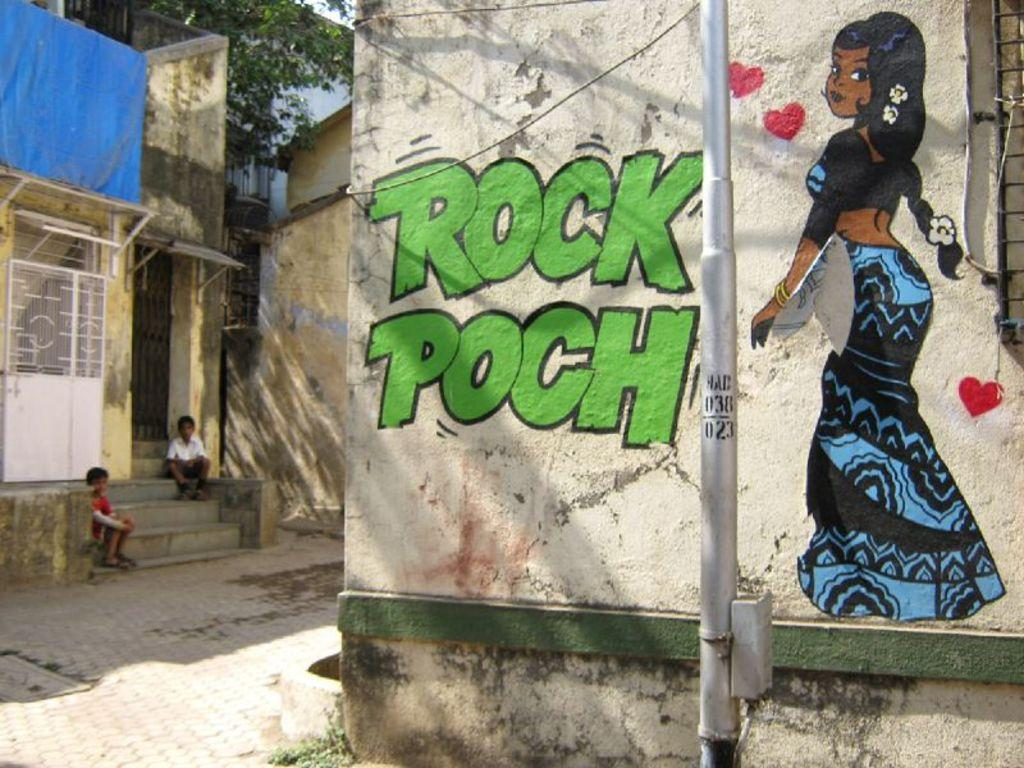What is on the wall in the image? There is a painting on the wall in the image. Where are the kids located in the image? The two kids are sitting on the staircase on the left side. What can be seen in the middle of the image? There are houses in the middle of the image. What type of vegetation is at the top of the image? There is a tree at the top of the image. What type of soda is being served in the image? There is no soda present in the image. What is the texture of the tree at the top of the image? The texture of the tree cannot be determined from the image alone, as it is a two-dimensional representation. 